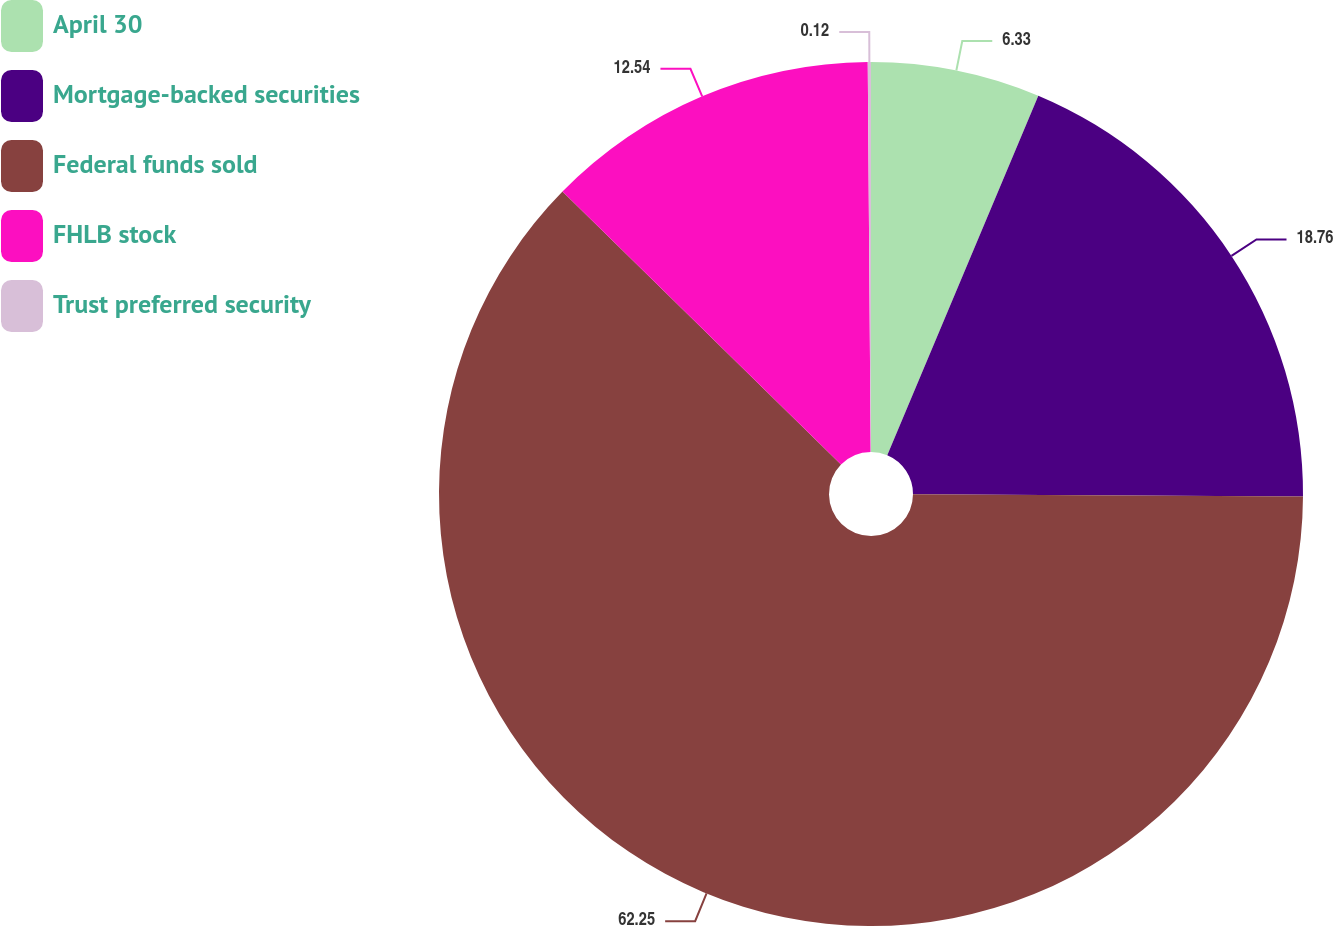Convert chart. <chart><loc_0><loc_0><loc_500><loc_500><pie_chart><fcel>April 30<fcel>Mortgage-backed securities<fcel>Federal funds sold<fcel>FHLB stock<fcel>Trust preferred security<nl><fcel>6.33%<fcel>18.76%<fcel>62.25%<fcel>12.54%<fcel>0.12%<nl></chart> 